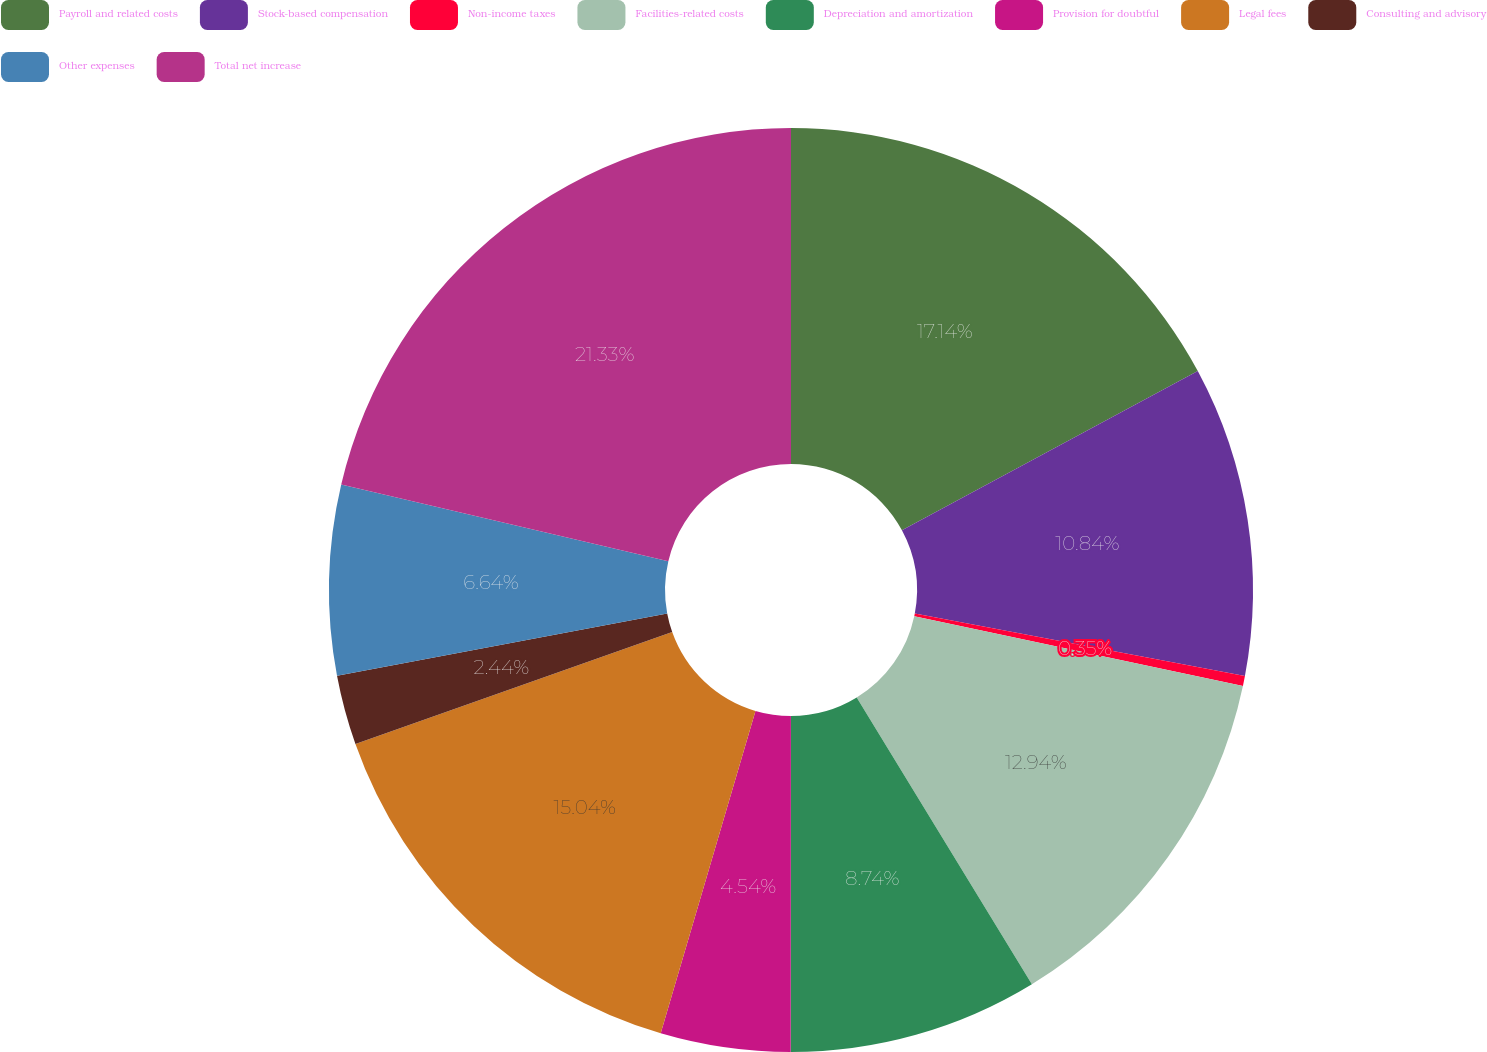<chart> <loc_0><loc_0><loc_500><loc_500><pie_chart><fcel>Payroll and related costs<fcel>Stock-based compensation<fcel>Non-income taxes<fcel>Facilities-related costs<fcel>Depreciation and amortization<fcel>Provision for doubtful<fcel>Legal fees<fcel>Consulting and advisory<fcel>Other expenses<fcel>Total net increase<nl><fcel>17.14%<fcel>10.84%<fcel>0.35%<fcel>12.94%<fcel>8.74%<fcel>4.54%<fcel>15.04%<fcel>2.44%<fcel>6.64%<fcel>21.33%<nl></chart> 